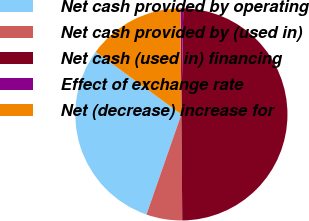Convert chart. <chart><loc_0><loc_0><loc_500><loc_500><pie_chart><fcel>Net cash provided by operating<fcel>Net cash provided by (used in)<fcel>Net cash (used in) financing<fcel>Effect of exchange rate<fcel>Net (decrease) increase for<nl><fcel>29.7%<fcel>5.47%<fcel>49.58%<fcel>0.42%<fcel>14.82%<nl></chart> 